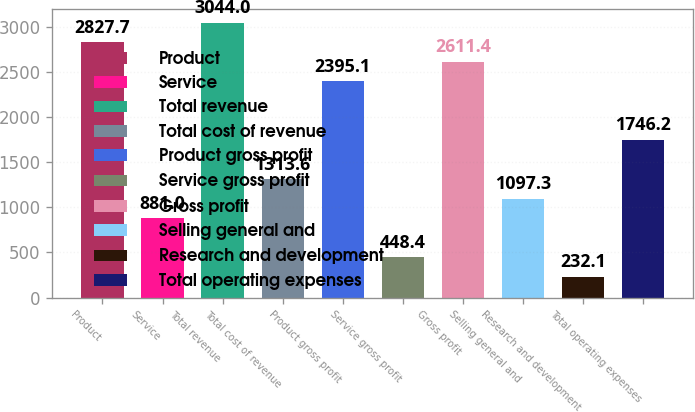Convert chart to OTSL. <chart><loc_0><loc_0><loc_500><loc_500><bar_chart><fcel>Product<fcel>Service<fcel>Total revenue<fcel>Total cost of revenue<fcel>Product gross profit<fcel>Service gross profit<fcel>Gross profit<fcel>Selling general and<fcel>Research and development<fcel>Total operating expenses<nl><fcel>2827.7<fcel>881<fcel>3044<fcel>1313.6<fcel>2395.1<fcel>448.4<fcel>2611.4<fcel>1097.3<fcel>232.1<fcel>1746.2<nl></chart> 